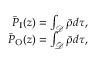Convert formula to latex. <formula><loc_0><loc_0><loc_500><loc_500>\begin{array} { r } { \bar { P } _ { I } ( z ) = \int _ { \mathcal { D } } \bar { \rho } d \tau , } \\ { \bar { P } _ { O } ( z ) = \int _ { \bar { \mathcal { D } } } \bar { \rho } d \tau , } \end{array}</formula> 